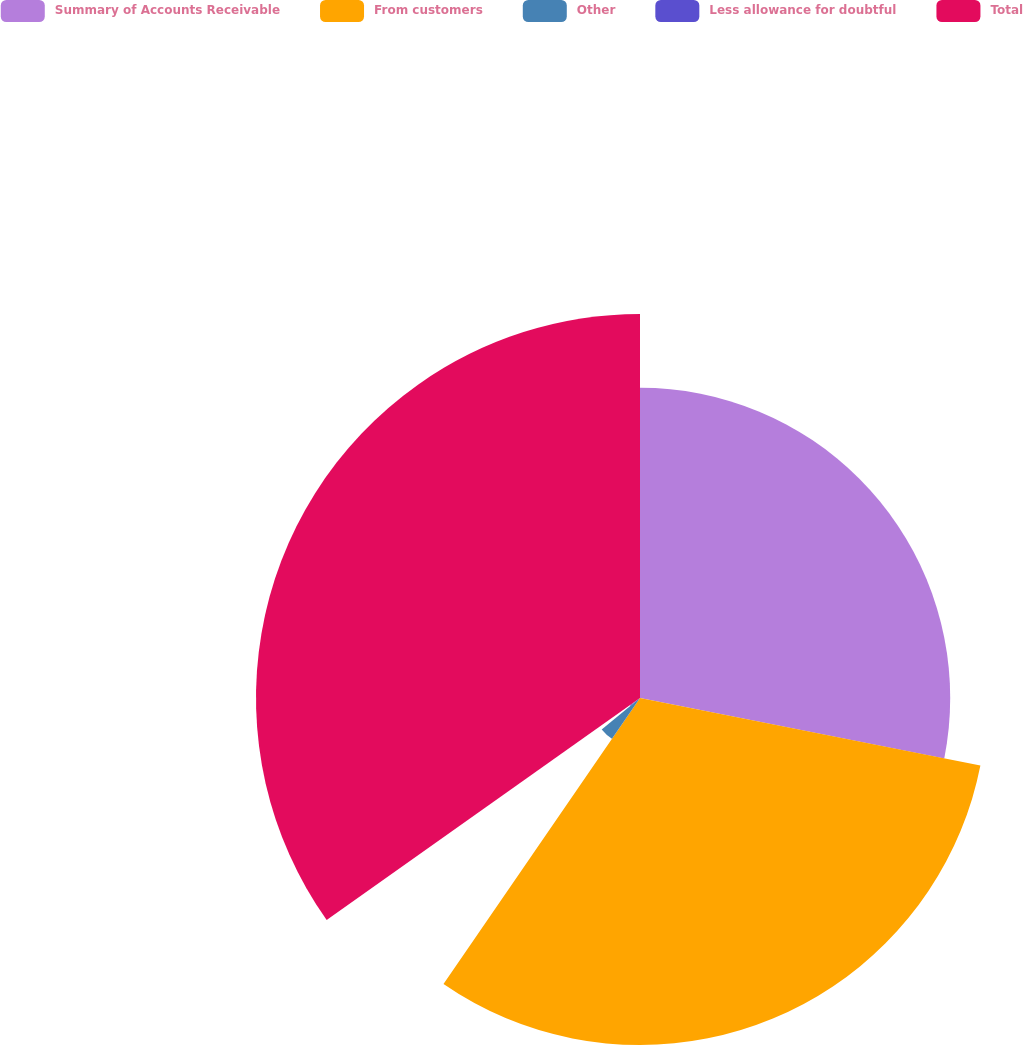Convert chart to OTSL. <chart><loc_0><loc_0><loc_500><loc_500><pie_chart><fcel>Summary of Accounts Receivable<fcel>From customers<fcel>Other<fcel>Less allowance for doubtful<fcel>Total<nl><fcel>28.12%<fcel>31.46%<fcel>4.49%<fcel>1.12%<fcel>34.81%<nl></chart> 